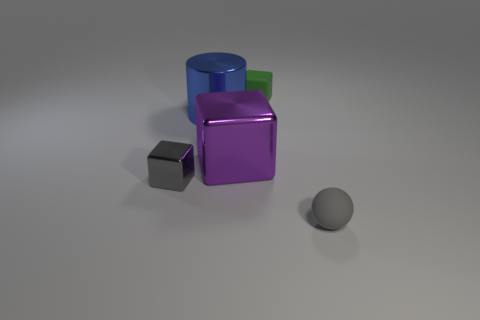How many objects are right of the blue cylinder and in front of the purple shiny block?
Provide a succinct answer. 1. How big is the matte thing that is left of the tiny gray object that is on the right side of the big blue thing?
Offer a very short reply. Small. Are there any other things that have the same material as the big blue cylinder?
Give a very brief answer. Yes. Are there more large blue things than red balls?
Your answer should be very brief. Yes. Do the rubber object behind the tiny metal thing and the small matte thing that is in front of the small gray cube have the same color?
Provide a succinct answer. No. There is a tiny gray metal thing that is to the left of the large blue cylinder; is there a purple cube to the left of it?
Your answer should be very brief. No. Is the number of big cylinders right of the tiny green cube less than the number of large blue objects right of the blue shiny cylinder?
Give a very brief answer. No. Is the small gray thing on the left side of the matte cube made of the same material as the tiny object that is on the right side of the tiny green cube?
Provide a short and direct response. No. How many tiny things are gray objects or gray matte things?
Your answer should be very brief. 2. The tiny object that is the same material as the tiny green cube is what shape?
Offer a very short reply. Sphere. 